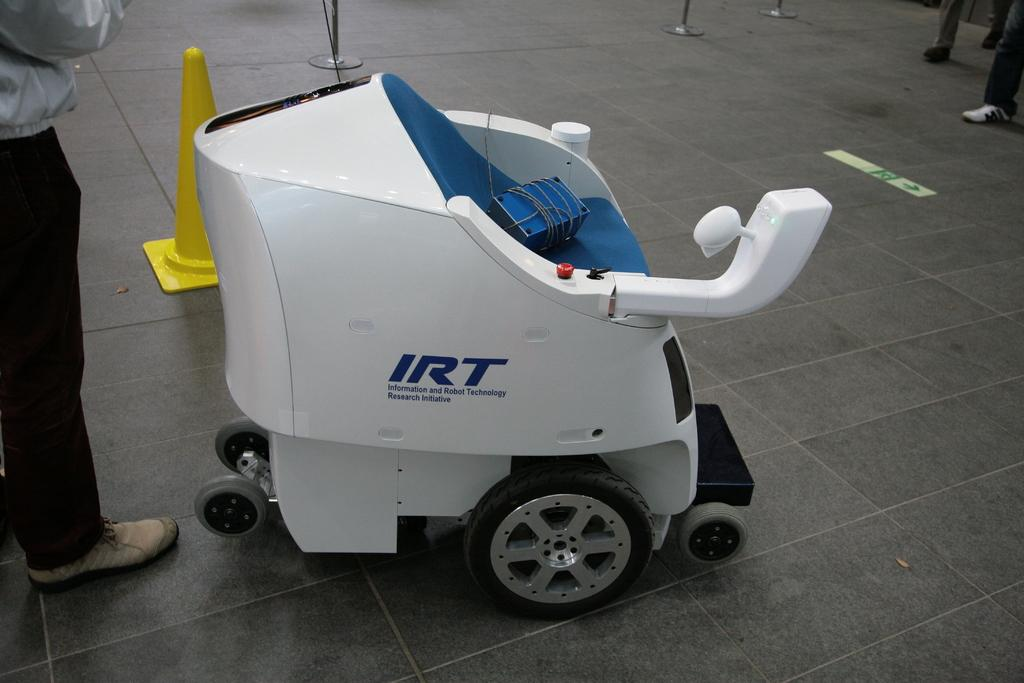Provide a one-sentence caption for the provided image. A robot from the Information and Robot Technology Research Initiative is on display. 